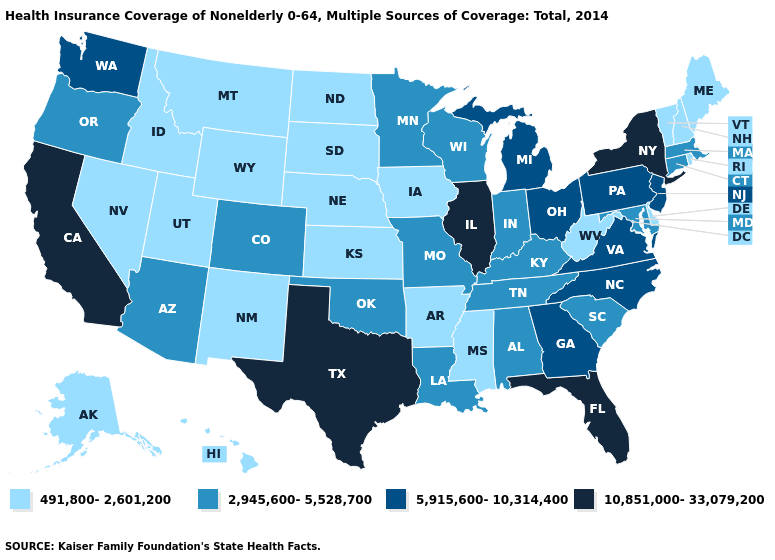Which states hav the highest value in the South?
Answer briefly. Florida, Texas. Does California have the lowest value in the USA?
Concise answer only. No. Which states have the lowest value in the West?
Keep it brief. Alaska, Hawaii, Idaho, Montana, Nevada, New Mexico, Utah, Wyoming. Among the states that border Pennsylvania , does Delaware have the lowest value?
Quick response, please. Yes. What is the value of New Mexico?
Answer briefly. 491,800-2,601,200. Does New Mexico have the lowest value in the West?
Be succinct. Yes. Does Colorado have a lower value than New York?
Keep it brief. Yes. Name the states that have a value in the range 2,945,600-5,528,700?
Quick response, please. Alabama, Arizona, Colorado, Connecticut, Indiana, Kentucky, Louisiana, Maryland, Massachusetts, Minnesota, Missouri, Oklahoma, Oregon, South Carolina, Tennessee, Wisconsin. Name the states that have a value in the range 5,915,600-10,314,400?
Answer briefly. Georgia, Michigan, New Jersey, North Carolina, Ohio, Pennsylvania, Virginia, Washington. What is the lowest value in states that border Georgia?
Concise answer only. 2,945,600-5,528,700. What is the lowest value in states that border Wyoming?
Give a very brief answer. 491,800-2,601,200. Is the legend a continuous bar?
Concise answer only. No. What is the value of Alaska?
Concise answer only. 491,800-2,601,200. Name the states that have a value in the range 2,945,600-5,528,700?
Quick response, please. Alabama, Arizona, Colorado, Connecticut, Indiana, Kentucky, Louisiana, Maryland, Massachusetts, Minnesota, Missouri, Oklahoma, Oregon, South Carolina, Tennessee, Wisconsin. Does Illinois have the highest value in the USA?
Short answer required. Yes. 